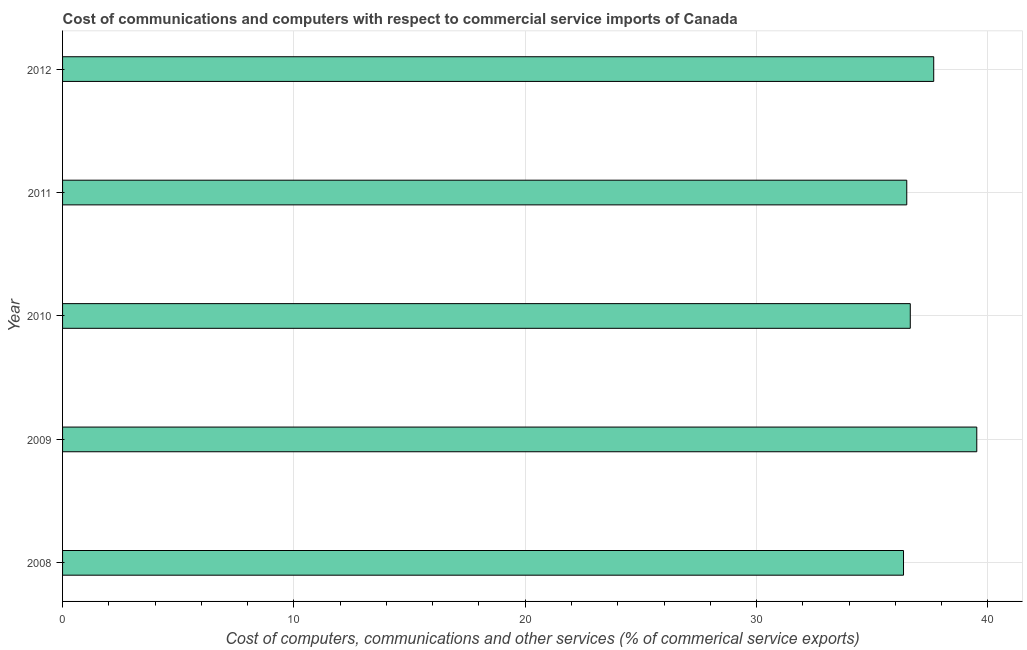What is the title of the graph?
Ensure brevity in your answer.  Cost of communications and computers with respect to commercial service imports of Canada. What is the label or title of the X-axis?
Your answer should be very brief. Cost of computers, communications and other services (% of commerical service exports). What is the  computer and other services in 2009?
Give a very brief answer. 39.52. Across all years, what is the maximum cost of communications?
Keep it short and to the point. 39.52. Across all years, what is the minimum cost of communications?
Provide a succinct answer. 36.35. In which year was the cost of communications minimum?
Your response must be concise. 2008. What is the sum of the  computer and other services?
Your response must be concise. 186.68. What is the difference between the  computer and other services in 2008 and 2012?
Offer a terse response. -1.3. What is the average  computer and other services per year?
Provide a succinct answer. 37.34. What is the median cost of communications?
Your answer should be compact. 36.65. What is the ratio of the  computer and other services in 2010 to that in 2012?
Your response must be concise. 0.97. Is the cost of communications in 2009 less than that in 2011?
Offer a very short reply. No. Is the difference between the cost of communications in 2010 and 2012 greater than the difference between any two years?
Offer a terse response. No. What is the difference between the highest and the second highest  computer and other services?
Your answer should be compact. 1.86. What is the difference between the highest and the lowest  computer and other services?
Offer a terse response. 3.17. In how many years, is the cost of communications greater than the average cost of communications taken over all years?
Give a very brief answer. 2. How many years are there in the graph?
Ensure brevity in your answer.  5. Are the values on the major ticks of X-axis written in scientific E-notation?
Provide a short and direct response. No. What is the Cost of computers, communications and other services (% of commerical service exports) in 2008?
Give a very brief answer. 36.35. What is the Cost of computers, communications and other services (% of commerical service exports) of 2009?
Ensure brevity in your answer.  39.52. What is the Cost of computers, communications and other services (% of commerical service exports) of 2010?
Provide a short and direct response. 36.65. What is the Cost of computers, communications and other services (% of commerical service exports) of 2011?
Keep it short and to the point. 36.49. What is the Cost of computers, communications and other services (% of commerical service exports) in 2012?
Offer a terse response. 37.66. What is the difference between the Cost of computers, communications and other services (% of commerical service exports) in 2008 and 2009?
Offer a terse response. -3.17. What is the difference between the Cost of computers, communications and other services (% of commerical service exports) in 2008 and 2010?
Make the answer very short. -0.29. What is the difference between the Cost of computers, communications and other services (% of commerical service exports) in 2008 and 2011?
Provide a succinct answer. -0.14. What is the difference between the Cost of computers, communications and other services (% of commerical service exports) in 2008 and 2012?
Your answer should be very brief. -1.31. What is the difference between the Cost of computers, communications and other services (% of commerical service exports) in 2009 and 2010?
Your answer should be compact. 2.88. What is the difference between the Cost of computers, communications and other services (% of commerical service exports) in 2009 and 2011?
Provide a short and direct response. 3.03. What is the difference between the Cost of computers, communications and other services (% of commerical service exports) in 2009 and 2012?
Offer a terse response. 1.86. What is the difference between the Cost of computers, communications and other services (% of commerical service exports) in 2010 and 2011?
Provide a succinct answer. 0.15. What is the difference between the Cost of computers, communications and other services (% of commerical service exports) in 2010 and 2012?
Offer a very short reply. -1.01. What is the difference between the Cost of computers, communications and other services (% of commerical service exports) in 2011 and 2012?
Ensure brevity in your answer.  -1.17. What is the ratio of the Cost of computers, communications and other services (% of commerical service exports) in 2008 to that in 2009?
Provide a succinct answer. 0.92. What is the ratio of the Cost of computers, communications and other services (% of commerical service exports) in 2008 to that in 2010?
Make the answer very short. 0.99. What is the ratio of the Cost of computers, communications and other services (% of commerical service exports) in 2008 to that in 2012?
Your answer should be very brief. 0.96. What is the ratio of the Cost of computers, communications and other services (% of commerical service exports) in 2009 to that in 2010?
Ensure brevity in your answer.  1.08. What is the ratio of the Cost of computers, communications and other services (% of commerical service exports) in 2009 to that in 2011?
Keep it short and to the point. 1.08. What is the ratio of the Cost of computers, communications and other services (% of commerical service exports) in 2009 to that in 2012?
Offer a very short reply. 1.05. What is the ratio of the Cost of computers, communications and other services (% of commerical service exports) in 2010 to that in 2012?
Provide a succinct answer. 0.97. What is the ratio of the Cost of computers, communications and other services (% of commerical service exports) in 2011 to that in 2012?
Make the answer very short. 0.97. 